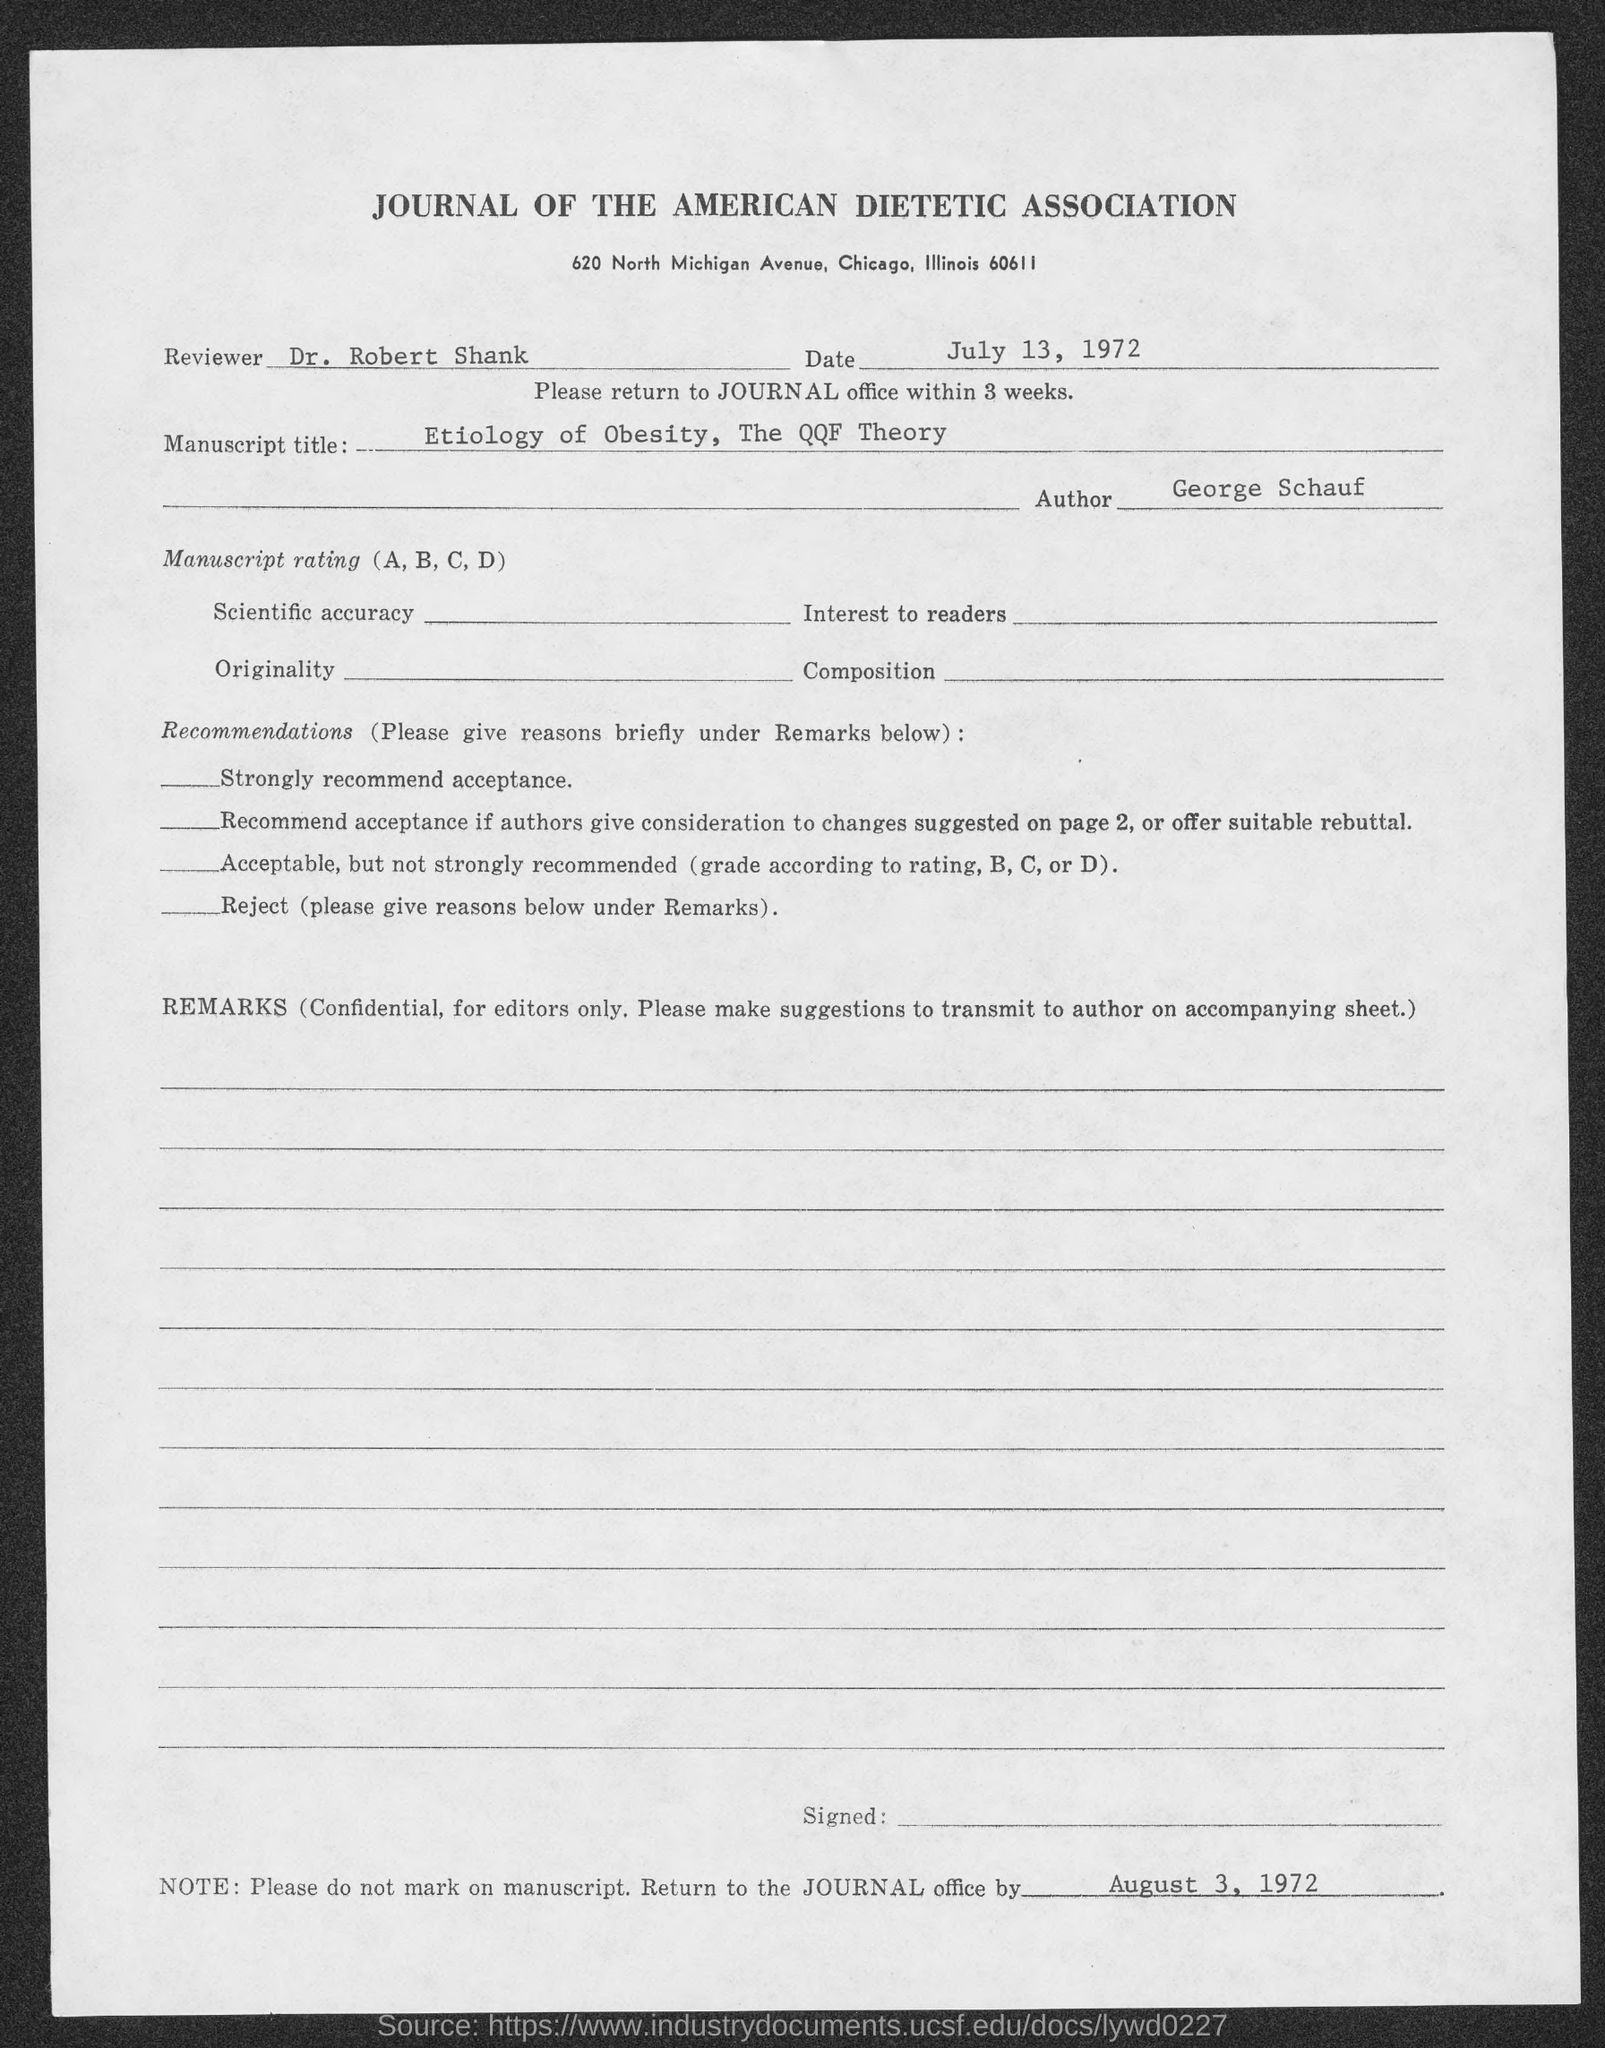Give some essential details in this illustration. The author of the document is George Schauf. The manuscript titled "Etiology of Obesity, The QQF Theory" is a document that aims to explore the causes and factors that contribute to obesity. As per the document, Dr. Robert Shank is the reviewer. The issued date of this document is July 13, 1972. The Journal of the American Dietetic Association is mentioned in the header of the document. 